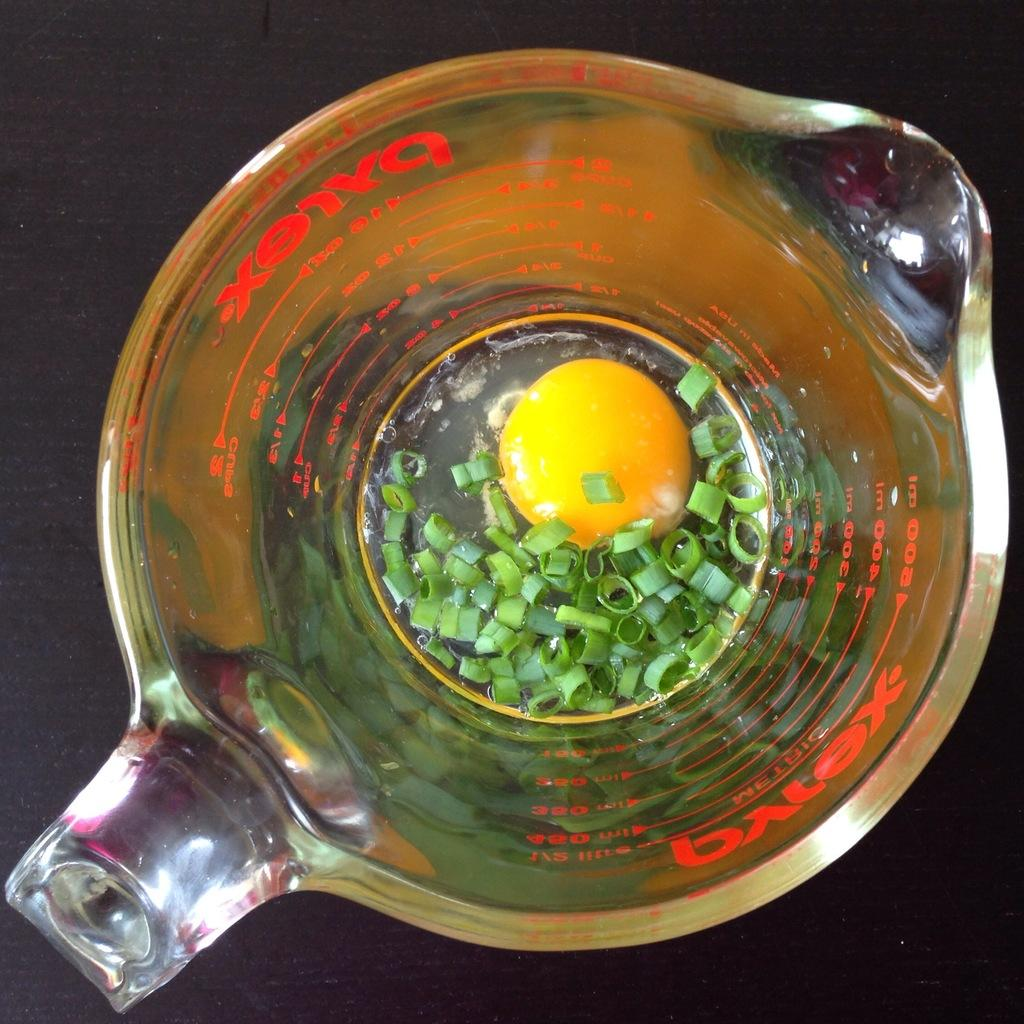<image>
Describe the image concisely. Beaker by Pyrex with an egg and some onions inside. 